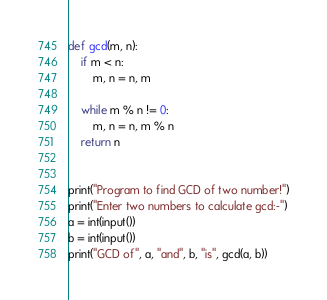<code> <loc_0><loc_0><loc_500><loc_500><_Python_>def gcd(m, n):
    if m < n:
        m, n = n, m

    while m % n != 0:
        m, n = n, m % n
    return n


print("Program to find GCD of two number!")
print("Enter two numbers to calculate gcd:-")
a = int(input())
b = int(input())
print("GCD of", a, "and", b, "is", gcd(a, b))
</code> 